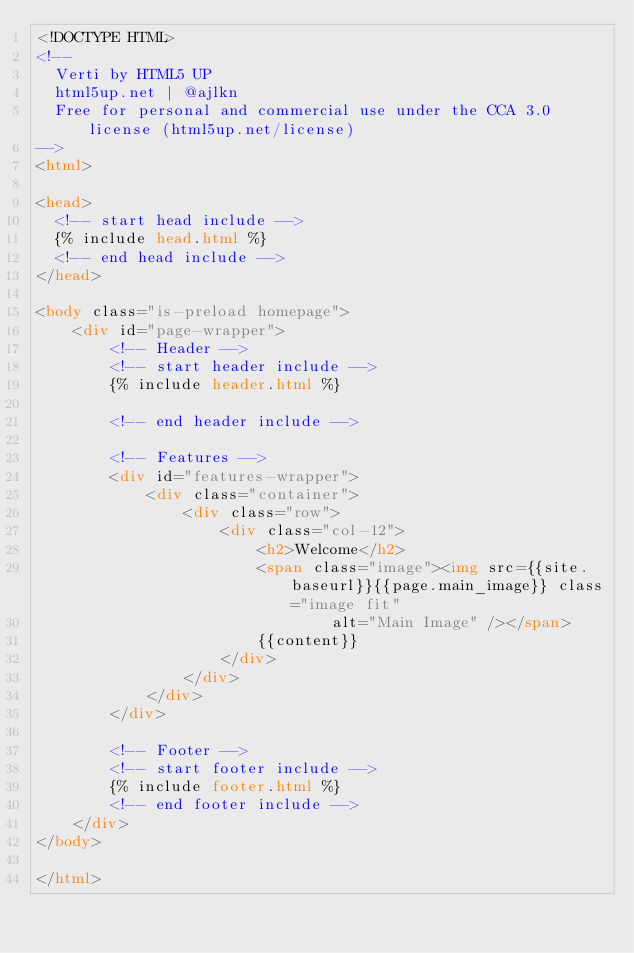<code> <loc_0><loc_0><loc_500><loc_500><_HTML_><!DOCTYPE HTML>
<!--
	Verti by HTML5 UP
	html5up.net | @ajlkn
	Free for personal and commercial use under the CCA 3.0 license (html5up.net/license)
-->
<html>

<head>
	<!-- start head include -->
	{% include head.html %}
	<!-- end head include -->
</head>

<body class="is-preload homepage">
    <div id="page-wrapper">
        <!-- Header -->
        <!-- start header include -->
        {% include header.html %}

        <!-- end header include -->

        <!-- Features -->
        <div id="features-wrapper">
            <div class="container">
                <div class="row">
                    <div class="col-12">
                        <h2>Welcome</h2>
                        <span class="image"><img src={{site.baseurl}}{{page.main_image}} class="image fit"
                                alt="Main Image" /></span>
                        {{content}}
                    </div>
                </div>
            </div>
        </div>

        <!-- Footer -->
        <!-- start footer include -->
        {% include footer.html %}
        <!-- end footer include -->
    </div>
</body>

</html></code> 